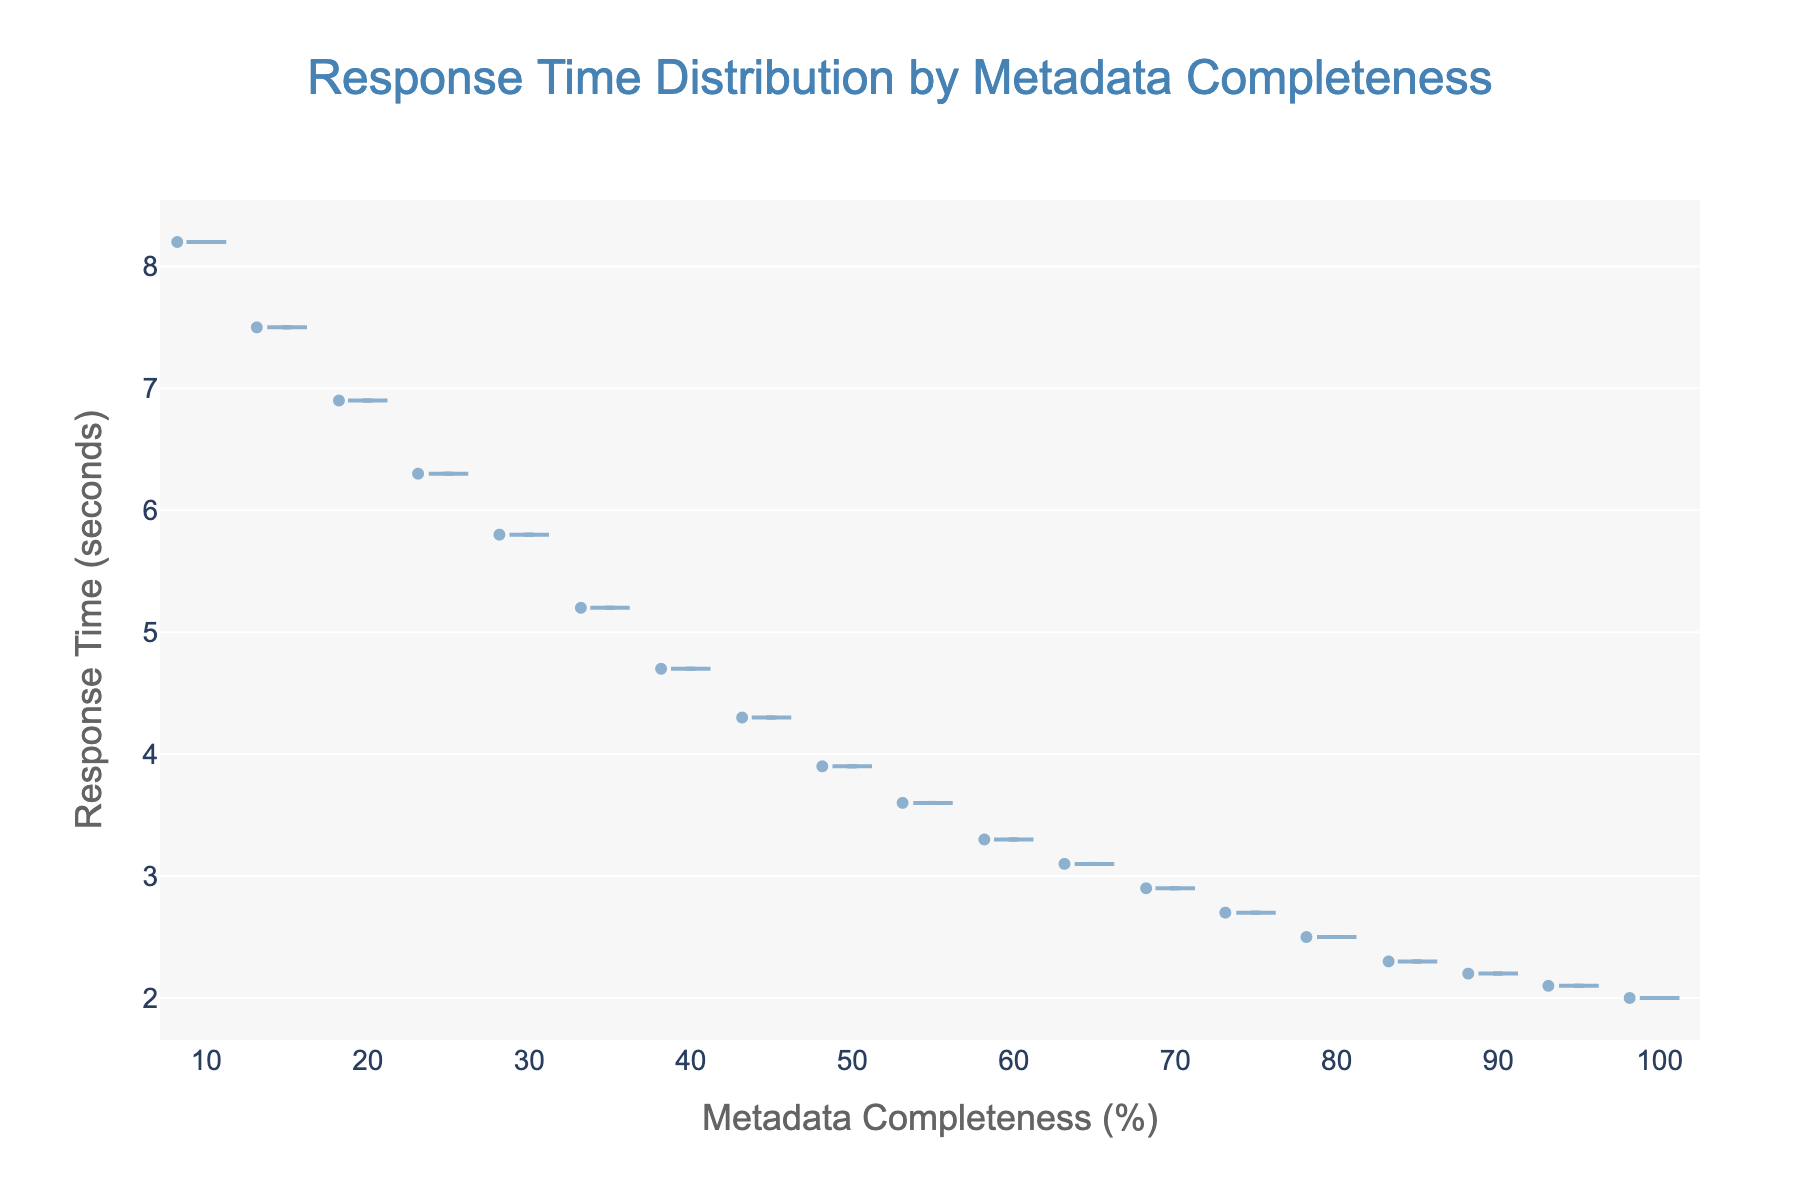What is the title of the plot? The title of the plot is prominently displayed at the top and usually summarizes the main focus of the figure.
Answer: Response Time Distribution by Metadata Completeness What is the meaning of the x-axis? The x-axis label describes what the horizontal axis represents in the plot, which is indicated at the bottom.
Answer: Metadata Completeness (%) How many data points are there in the figure? Each dot or point in the violin plot represents a data point, and counting these gives the total number. In this plot, for each level of metadata completeness (10% intervals), there is one response time data point. Therefore, there are 19 points from 10% to 100%.
Answer: 19 What is the trend shown by the response time as metadata completeness increases? Observing the direction in which the data points move as the x-axis values increase indicates the trend.
Answer: Response time decreases Compare the response times at 20% and 80% metadata completeness. To compare two points, locate them on the plot for their respective x-axis values and read their corresponding y-axis values. At 20%, the response time is 6.9 seconds, and at 80%, it is 2.5 seconds.
Answer: 20%: 6.9s, 80%: 2.5s What is the median response time shown in the plot? In a violin plot, the median is often illustrated by a visible line within the shaded area.
Answer: 4.7 seconds At which level(s) of metadata completeness does the response time drop below 4 seconds? Identify and list the metadata completeness levels from the x-axis at which the response time data points are below 4 seconds from the y-axis.
Answer: 50%, 55%, 60%, 65%, 70%, 75%, 80%, 85%, 90%, 95%, 100% What does the blue shading area in the violin plot represent? The shaded area of the violin plot demonstrates the density of the data points within a particular range of data values.
Answer: Density of response time data points Find the difference in response time between metadata completeness levels of 30% and 60%. Subtract the response time at 60% metadata completeness from that at 30%. At 30%, the response time is 5.8 seconds, and at 60%, it is 3.3 seconds.
Answer: 2.5 seconds Which metadata completeness level corresponds to the lowest response time in the plot? Observing the lowest point on the y-axis associated with any x-axis value indicates the level of metadata completeness with the lowest response time.
Answer: 100% 